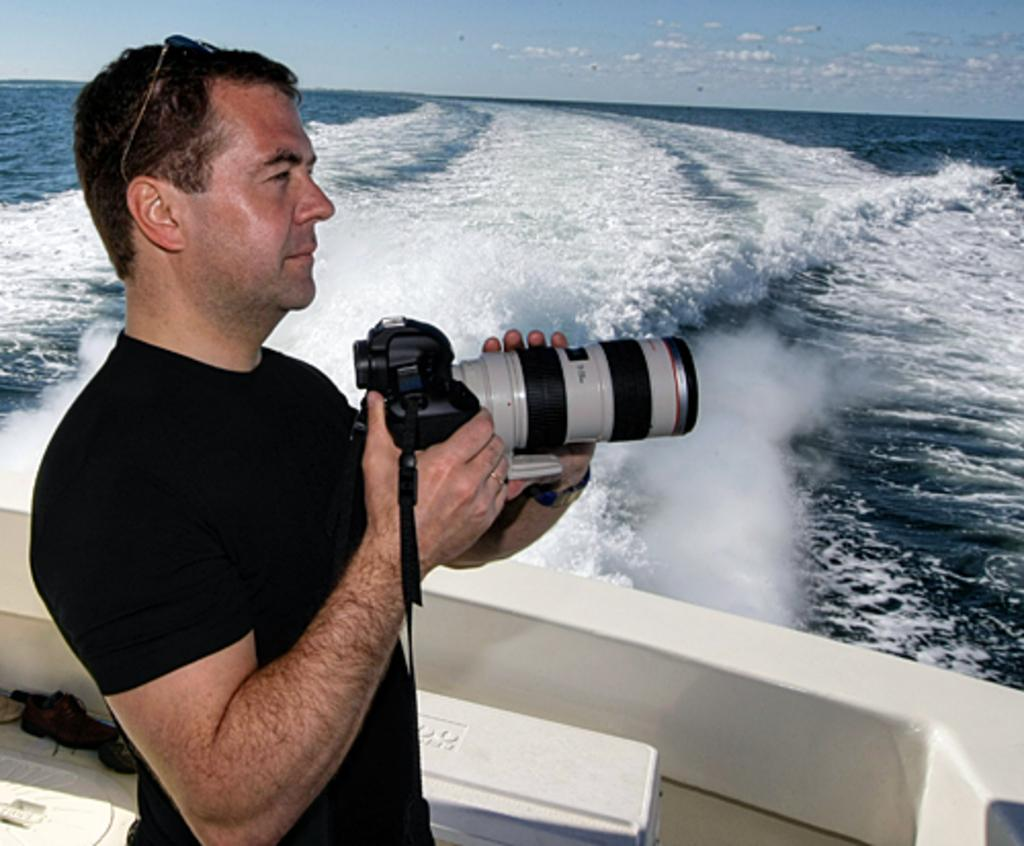What is present in the image? There is a man in the image. What is the man holding in his hands? The man is holding a camera in his hands. What can be seen in the background of the image? There is water visible in the image. How many letters can be seen floating in the water in the image? There are no letters visible in the water in the image. What type of toppings can be seen on the pizzas in the image? There are no pizzas present in the image. Can you describe the bean that is growing near the man in the image? There is no bean growing near the man in the image. 